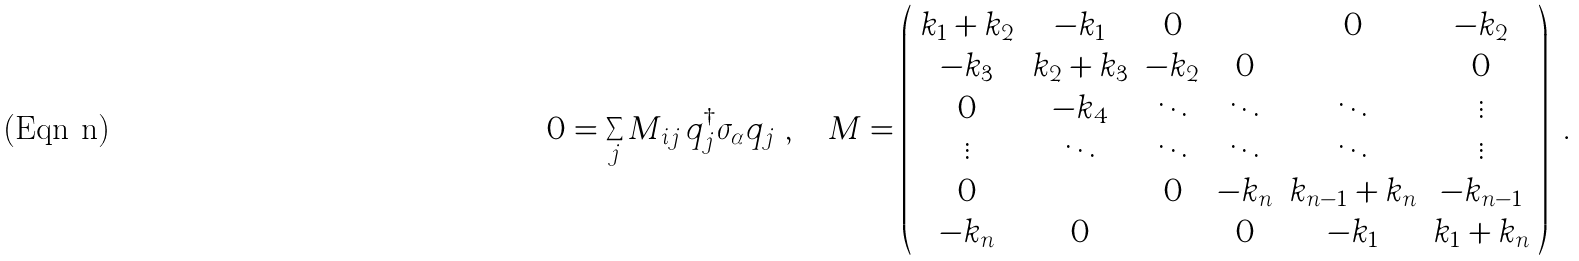Convert formula to latex. <formula><loc_0><loc_0><loc_500><loc_500>0 = \sum _ { j } M _ { i j } \, q _ { j } ^ { \dagger } \sigma _ { \alpha } q _ { j } \ , \quad M = \left ( \begin{array} { c c c c c c } k _ { 1 } + k _ { 2 } & - k _ { 1 } & 0 & \cdots & 0 & - k _ { 2 } \\ - k _ { 3 } & k _ { 2 } + k _ { 3 } & - k _ { 2 } & 0 & \cdots & 0 \\ 0 & - k _ { 4 } & \ddots & \ddots & \ddots & \vdots \\ \vdots & \ddots & \ddots & \ddots & \ddots & \vdots \\ 0 & \cdots & 0 & - k _ { n } & k _ { n - 1 } + k _ { n } & - k _ { n - 1 } \\ - k _ { n } & 0 & \cdots & 0 & - k _ { 1 } & k _ { 1 } + k _ { n } \end{array} \right ) \ .</formula> 